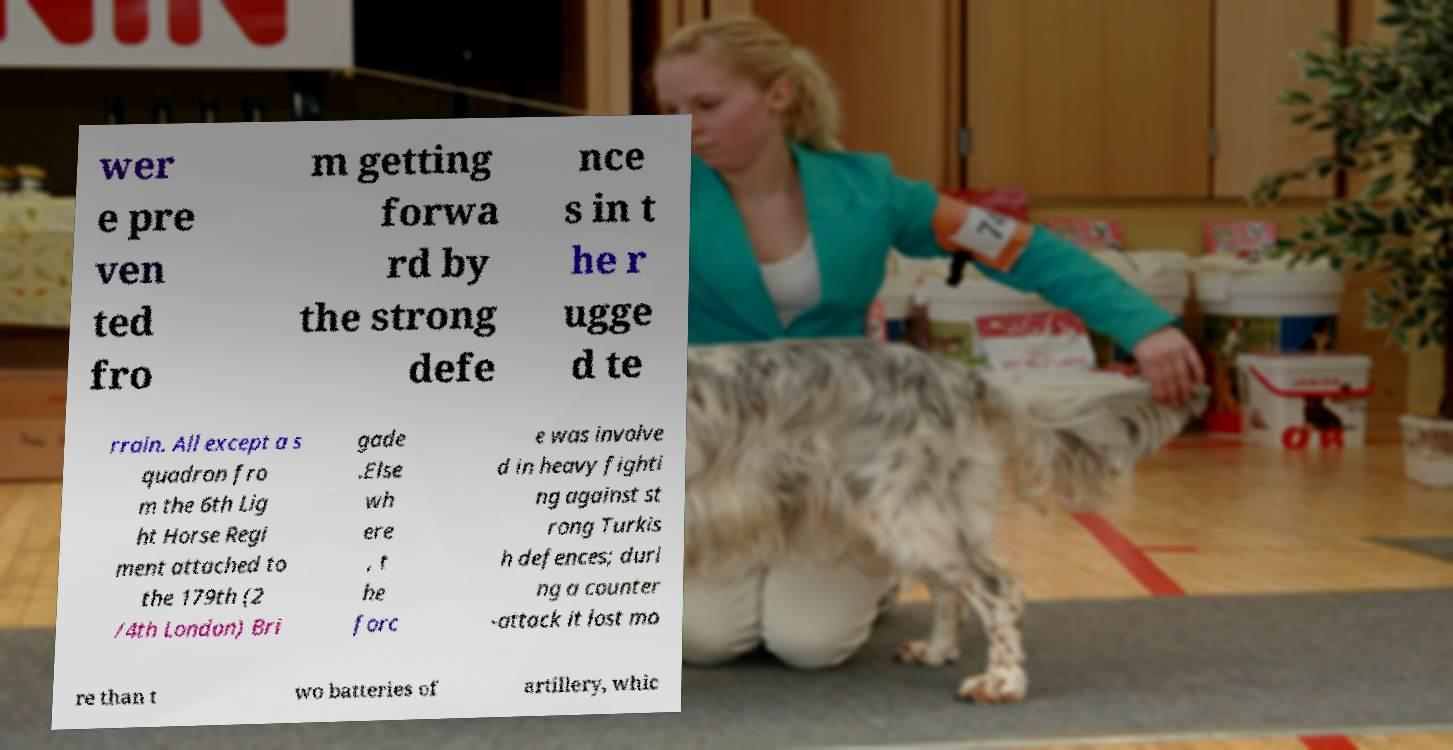Please identify and transcribe the text found in this image. wer e pre ven ted fro m getting forwa rd by the strong defe nce s in t he r ugge d te rrain. All except a s quadron fro m the 6th Lig ht Horse Regi ment attached to the 179th (2 /4th London) Bri gade .Else wh ere , t he forc e was involve d in heavy fighti ng against st rong Turkis h defences; duri ng a counter -attack it lost mo re than t wo batteries of artillery, whic 